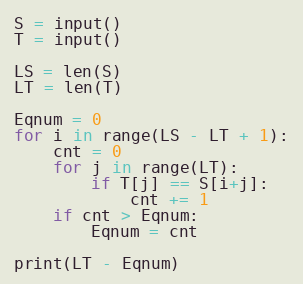<code> <loc_0><loc_0><loc_500><loc_500><_Python_>S = input()
T = input()

LS = len(S)
LT = len(T)

Eqnum = 0
for i in range(LS - LT + 1):
    cnt = 0
    for j in range(LT):
        if T[j] == S[i+j]:
            cnt += 1
    if cnt > Eqnum:
        Eqnum = cnt

print(LT - Eqnum)
</code> 